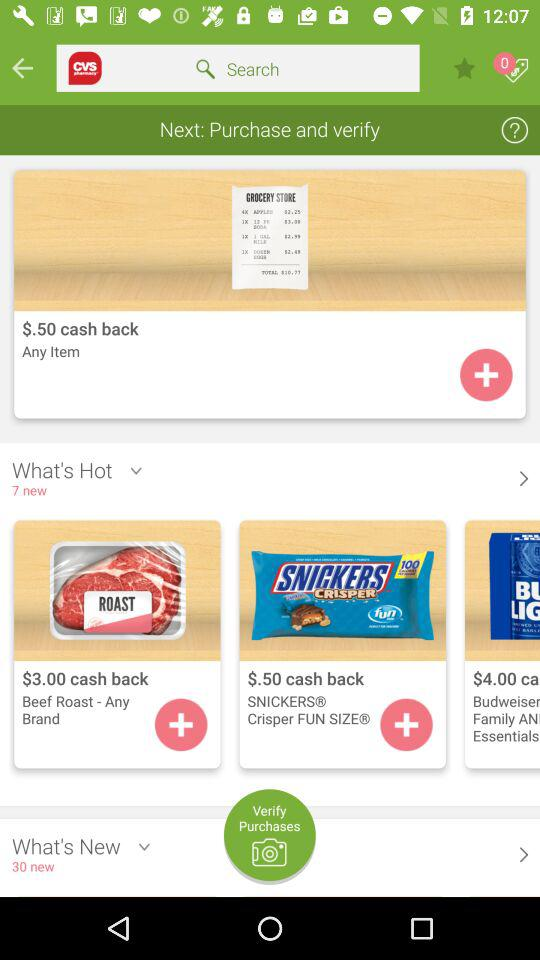How much cash back is offered for the item Beef Roast - Any Brand?
Answer the question using a single word or phrase. $3.00 